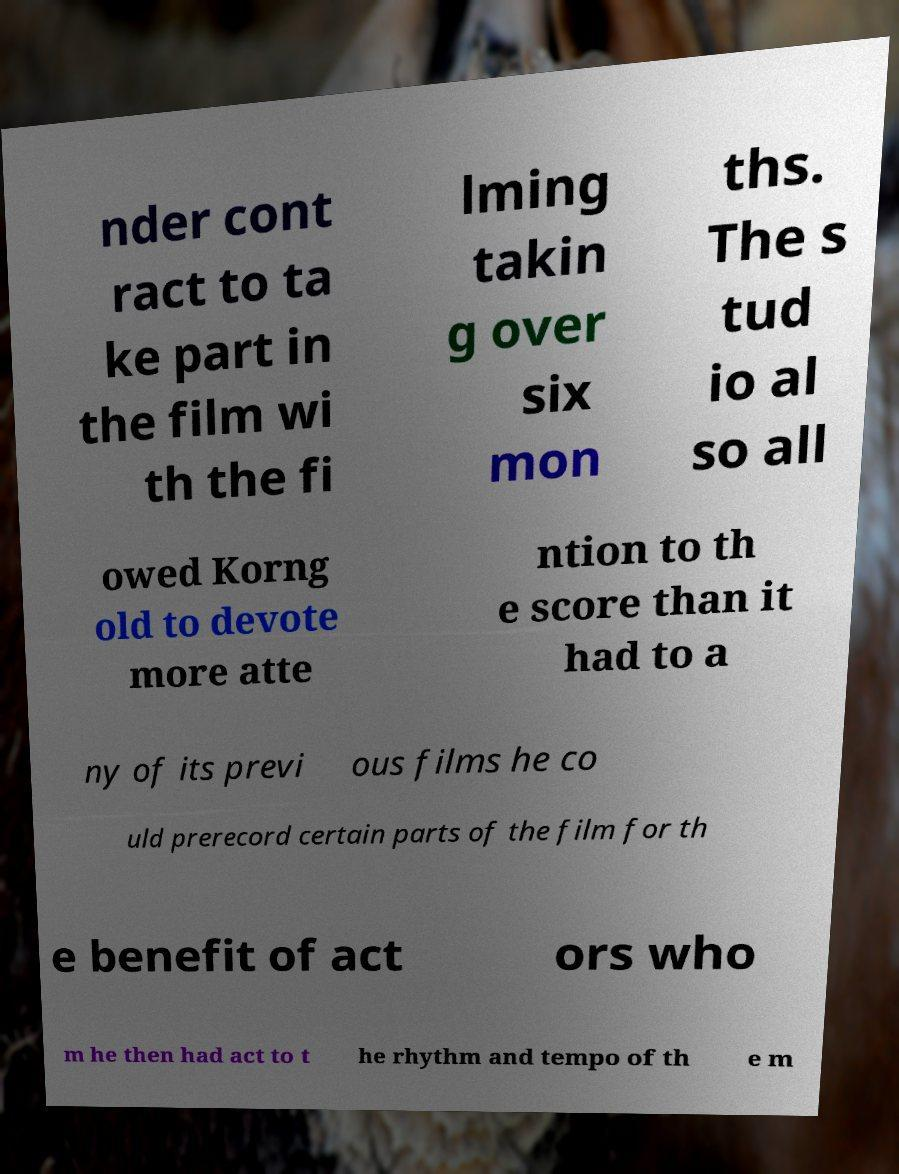Can you accurately transcribe the text from the provided image for me? nder cont ract to ta ke part in the film wi th the fi lming takin g over six mon ths. The s tud io al so all owed Korng old to devote more atte ntion to th e score than it had to a ny of its previ ous films he co uld prerecord certain parts of the film for th e benefit of act ors who m he then had act to t he rhythm and tempo of th e m 